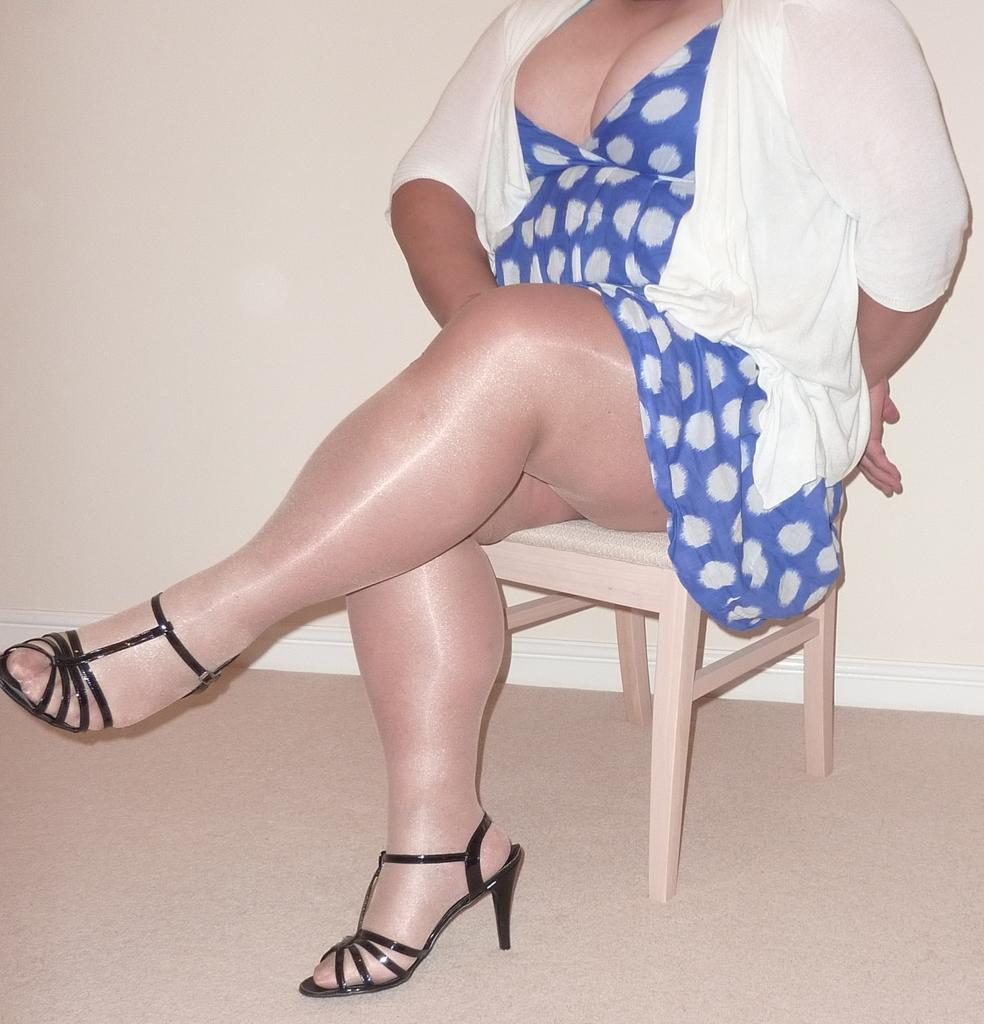Who is present in the image? There is a woman in the image. What type of footwear is the woman wearing? The woman is wearing sandals. What is the woman sitting on in the image? The woman is sitting on a stool. Where is the stool located in the image? The stool is on the floor. What can be seen in the background of the image? There is a wall in the background of the image. How many pets does the woman's aunt have in the image? There is no mention of pets or the woman's aunt in the image, so we cannot determine the number of pets she might have. 